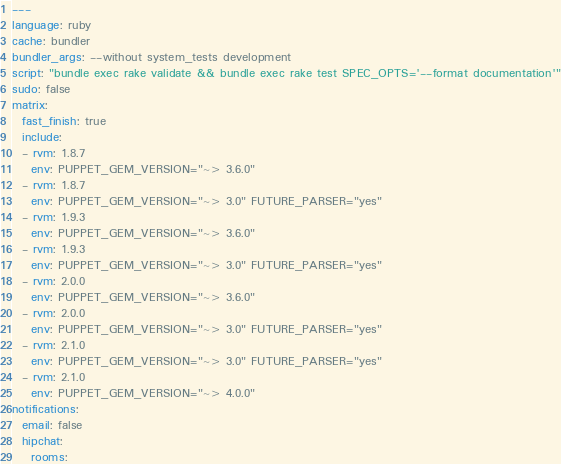Convert code to text. <code><loc_0><loc_0><loc_500><loc_500><_YAML_>---
language: ruby
cache: bundler
bundler_args: --without system_tests development
script: "bundle exec rake validate && bundle exec rake test SPEC_OPTS='--format documentation'"
sudo: false
matrix:
  fast_finish: true
  include:
  - rvm: 1.8.7
    env: PUPPET_GEM_VERSION="~> 3.6.0"
  - rvm: 1.8.7
    env: PUPPET_GEM_VERSION="~> 3.0" FUTURE_PARSER="yes"
  - rvm: 1.9.3
    env: PUPPET_GEM_VERSION="~> 3.6.0"
  - rvm: 1.9.3
    env: PUPPET_GEM_VERSION="~> 3.0" FUTURE_PARSER="yes"
  - rvm: 2.0.0
    env: PUPPET_GEM_VERSION="~> 3.6.0"
  - rvm: 2.0.0
    env: PUPPET_GEM_VERSION="~> 3.0" FUTURE_PARSER="yes"
  - rvm: 2.1.0
    env: PUPPET_GEM_VERSION="~> 3.0" FUTURE_PARSER="yes"
  - rvm: 2.1.0
    env: PUPPET_GEM_VERSION="~> 4.0.0"
notifications:
  email: false
  hipchat:
    rooms:</code> 